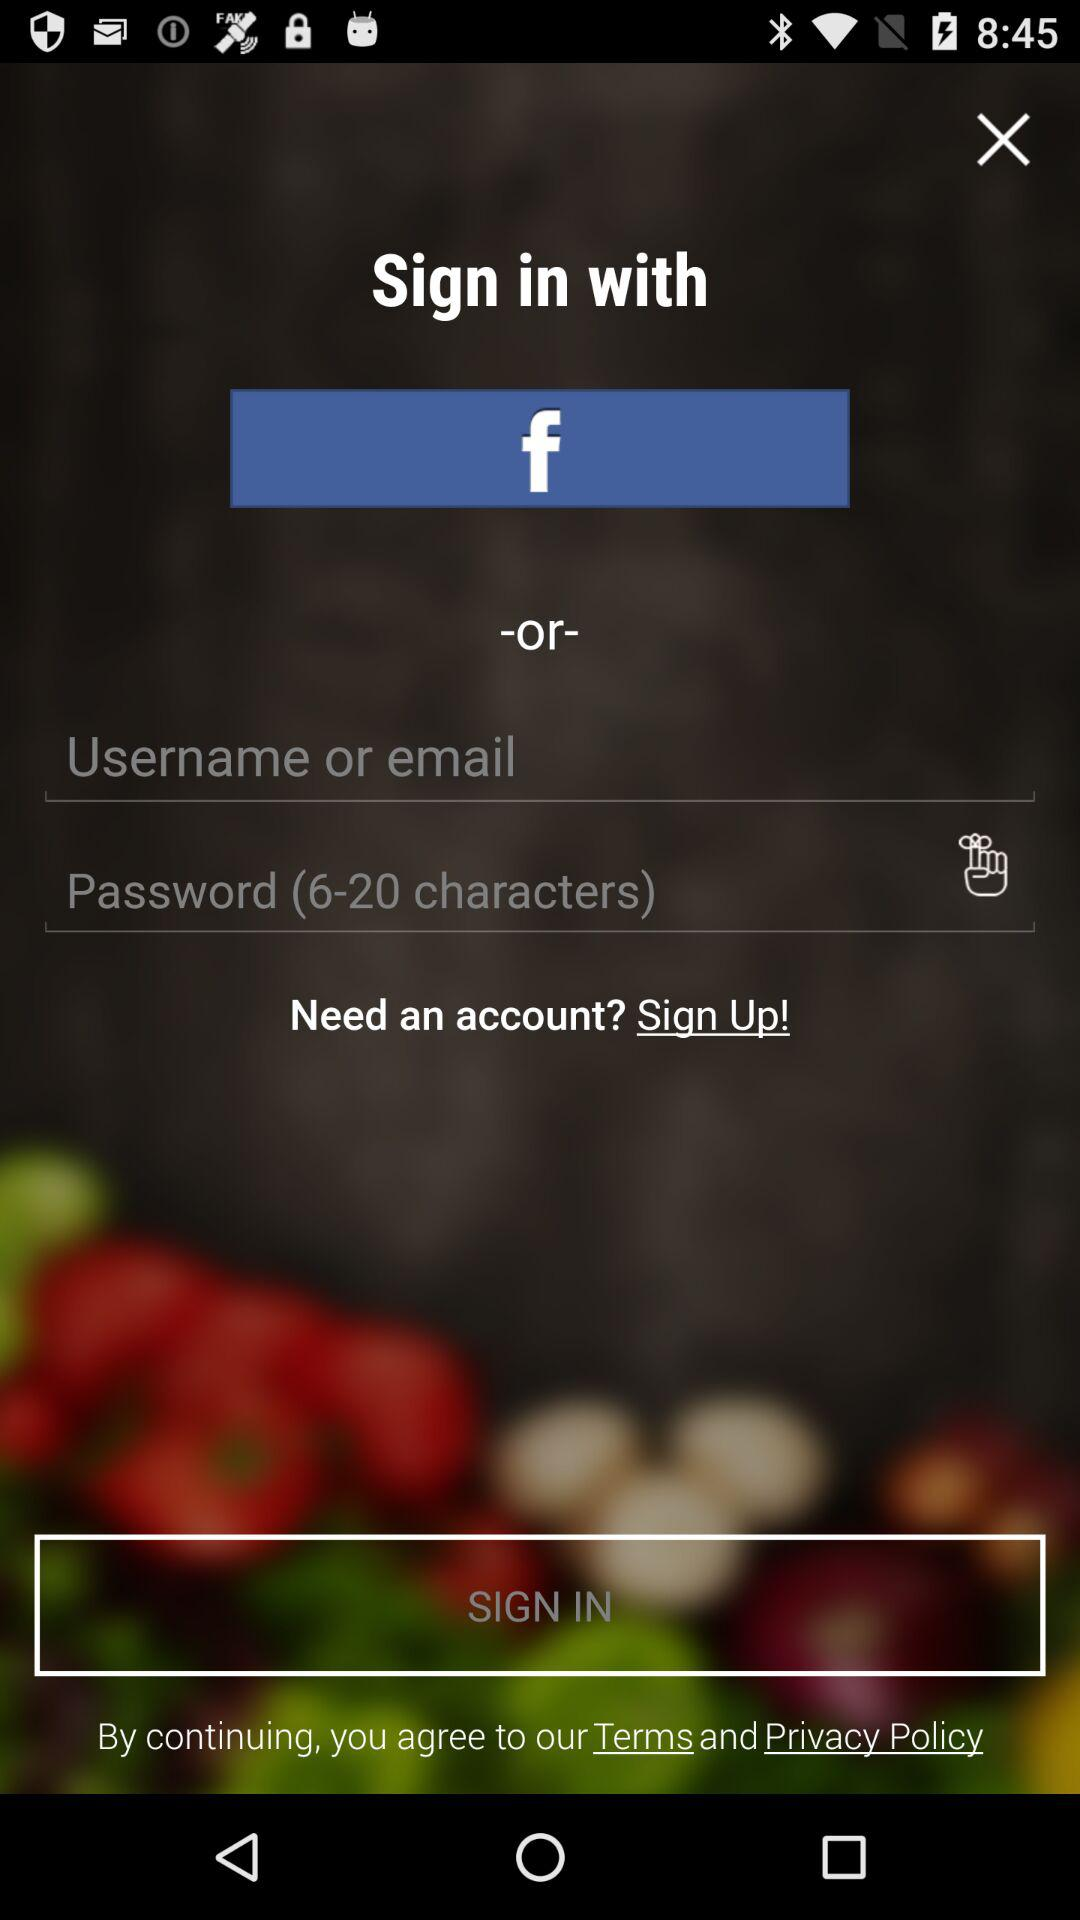How many numbers are required to create a password?
When the provided information is insufficient, respond with <no answer>. <no answer> 